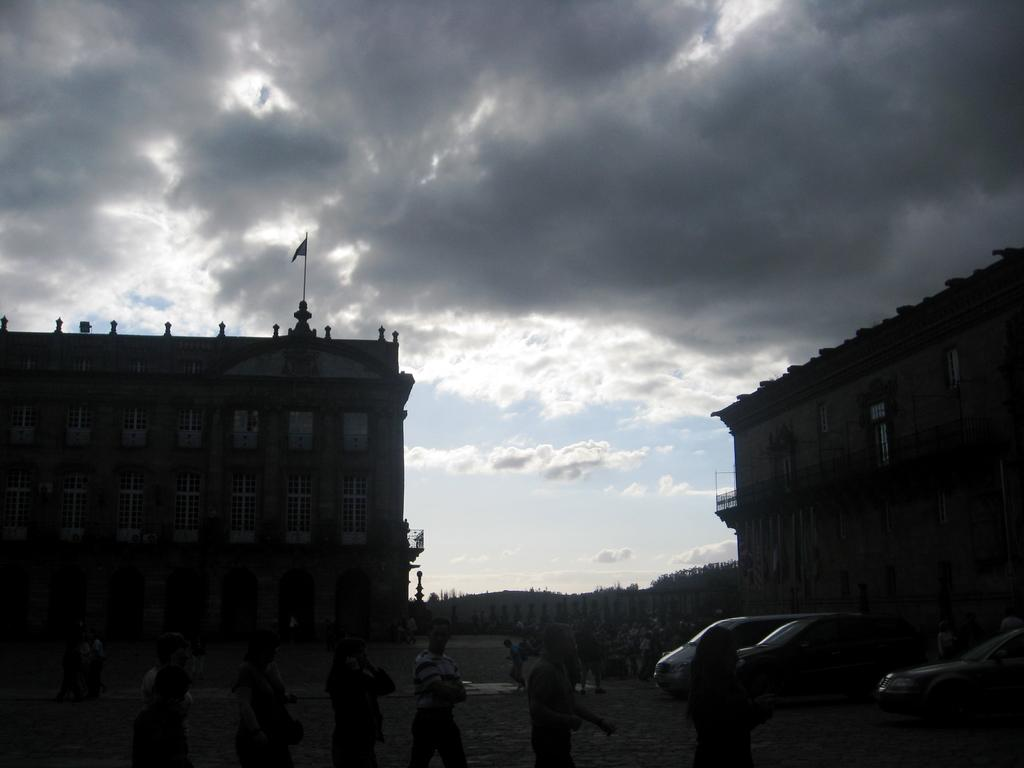What can be seen at the bottom of the image? There are people standing at the bottom of the image. What is present on the road in the image? There are vehicles on the road in the image. What is visible in the background of the image? There are buildings, windows, a flag on a building, trees, and clouds in the sky in the background of the image. What type of wool is being used to make the credit card in the image? There is no credit card or wool present in the image. How many sacks are visible in the image? There are no sacks visible in the image. 